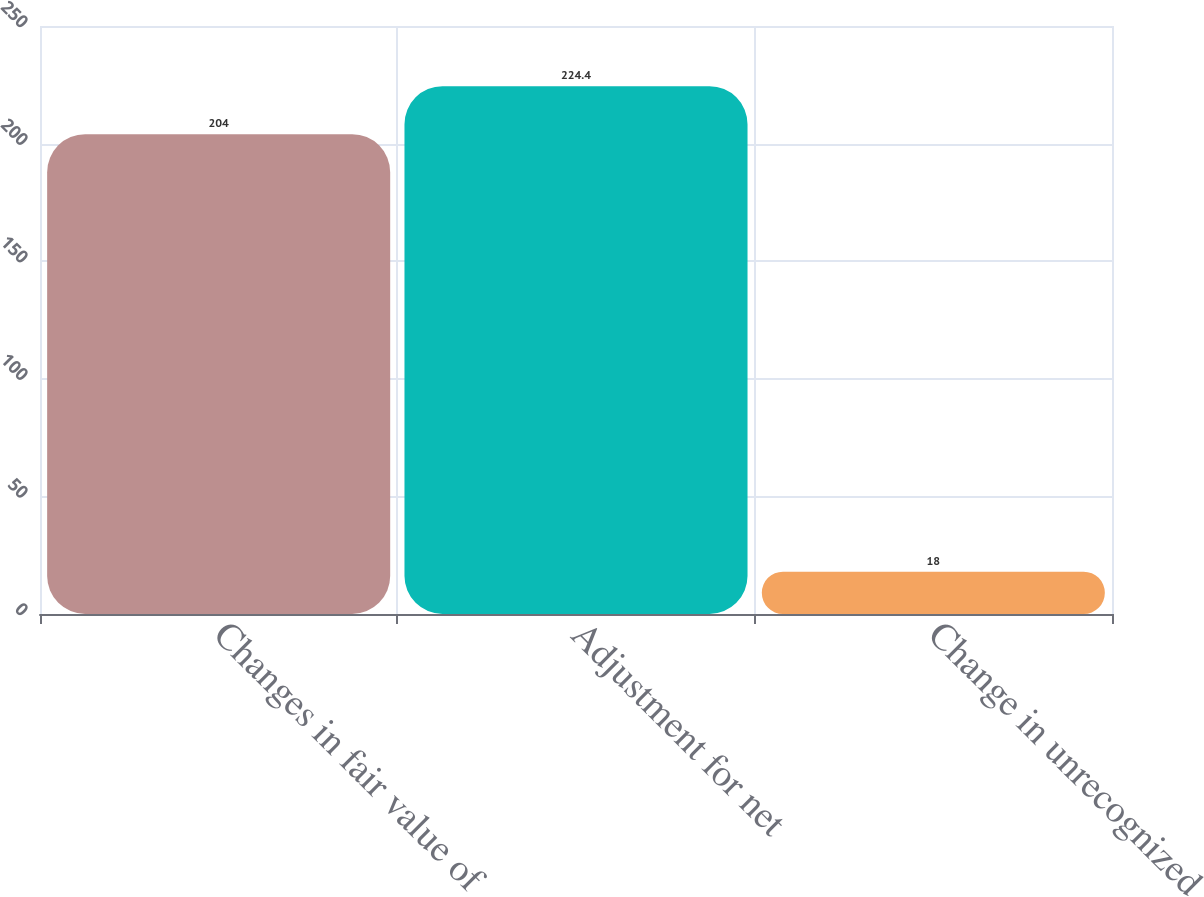<chart> <loc_0><loc_0><loc_500><loc_500><bar_chart><fcel>Changes in fair value of<fcel>Adjustment for net<fcel>Change in unrecognized<nl><fcel>204<fcel>224.4<fcel>18<nl></chart> 